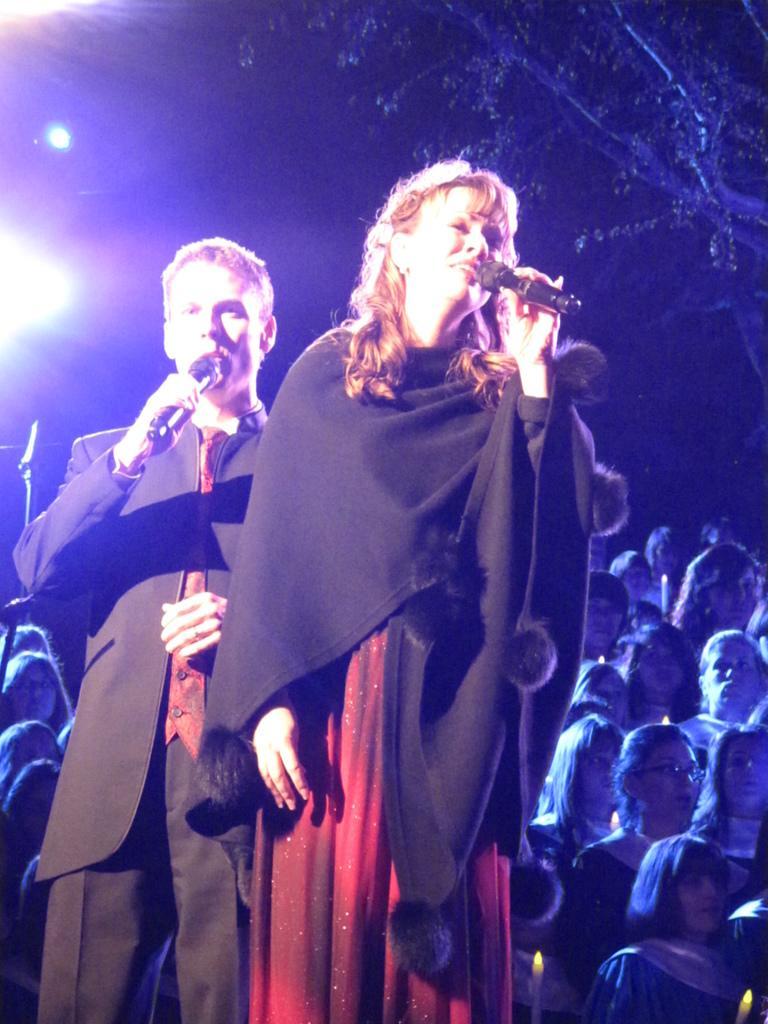Describe this image in one or two sentences. In this image there is a lady and a man holding mics in their hands and singing, in the background there are people standing. 